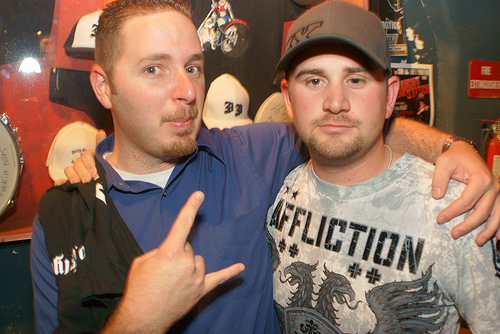<image>
Is there a mens in front of the hats? Yes. The mens is positioned in front of the hats, appearing closer to the camera viewpoint. 